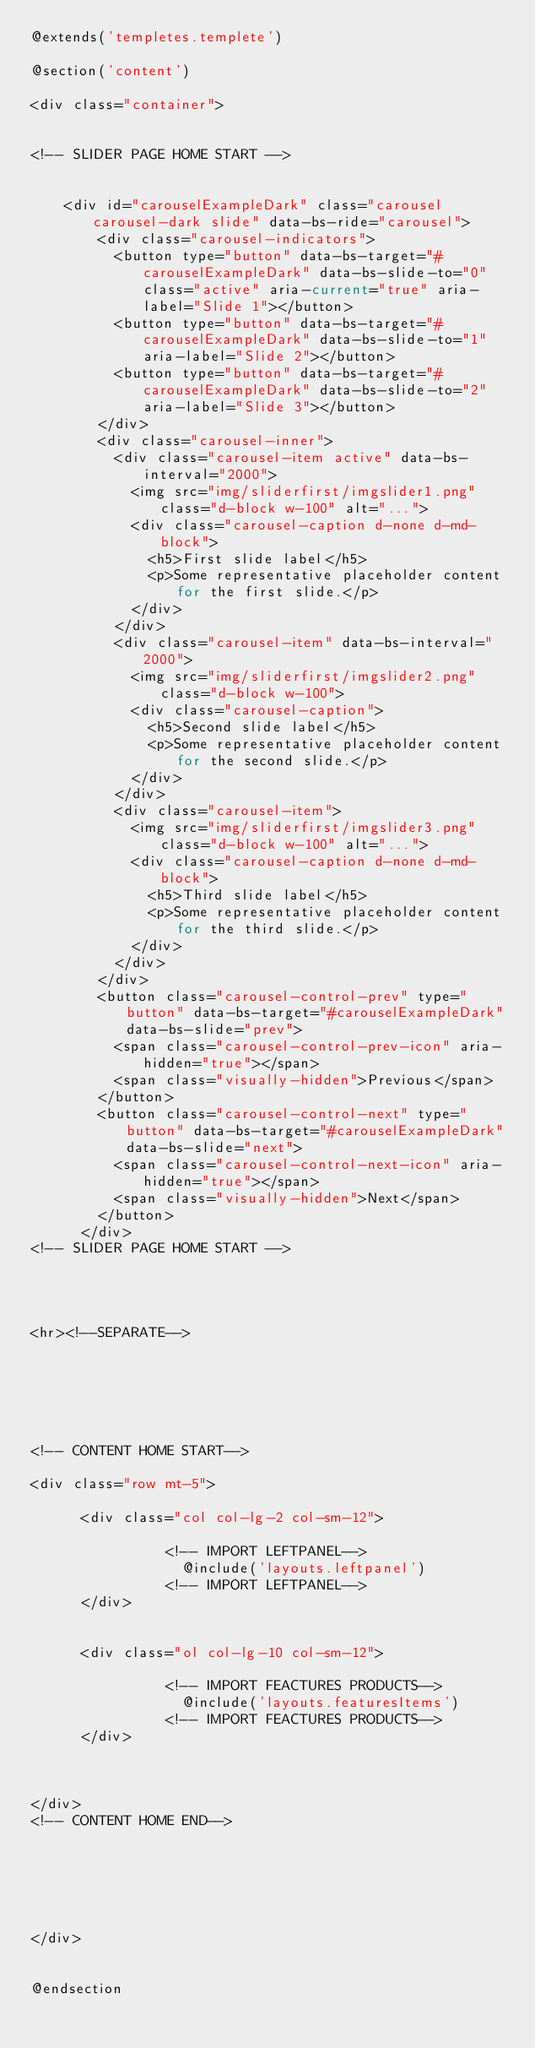<code> <loc_0><loc_0><loc_500><loc_500><_PHP_>@extends('templetes.templete')

@section('content')

<div class="container">


<!-- SLIDER PAGE HOME START -->


    <div id="carouselExampleDark" class="carousel carousel-dark slide" data-bs-ride="carousel">
        <div class="carousel-indicators">
          <button type="button" data-bs-target="#carouselExampleDark" data-bs-slide-to="0" class="active" aria-current="true" aria-label="Slide 1"></button>
          <button type="button" data-bs-target="#carouselExampleDark" data-bs-slide-to="1" aria-label="Slide 2"></button>
          <button type="button" data-bs-target="#carouselExampleDark" data-bs-slide-to="2" aria-label="Slide 3"></button>
        </div>
        <div class="carousel-inner">
          <div class="carousel-item active" data-bs-interval="2000">
            <img src="img/sliderfirst/imgslider1.png" class="d-block w-100" alt="...">
            <div class="carousel-caption d-none d-md-block">
              <h5>First slide label</h5>
              <p>Some representative placeholder content for the first slide.</p>
            </div>
          </div>
          <div class="carousel-item" data-bs-interval="2000">
            <img src="img/sliderfirst/imgslider2.png" class="d-block w-100">
            <div class="carousel-caption">
              <h5>Second slide label</h5>
              <p>Some representative placeholder content for the second slide.</p>
            </div>
          </div>
          <div class="carousel-item">
            <img src="img/sliderfirst/imgslider3.png" class="d-block w-100" alt="...">
            <div class="carousel-caption d-none d-md-block">
              <h5>Third slide label</h5>
              <p>Some representative placeholder content for the third slide.</p>
            </div>
          </div>
        </div>
        <button class="carousel-control-prev" type="button" data-bs-target="#carouselExampleDark" data-bs-slide="prev">
          <span class="carousel-control-prev-icon" aria-hidden="true"></span>
          <span class="visually-hidden">Previous</span>
        </button>
        <button class="carousel-control-next" type="button" data-bs-target="#carouselExampleDark" data-bs-slide="next">
          <span class="carousel-control-next-icon" aria-hidden="true"></span>
          <span class="visually-hidden">Next</span>
        </button>
      </div>
<!-- SLIDER PAGE HOME START -->




<hr><!--SEPARATE-->






<!-- CONTENT HOME START-->

<div class="row mt-5">

      <div class="col col-lg-2 col-sm-12">

                <!-- IMPORT LEFTPANEL-->
                  @include('layouts.leftpanel')
                <!-- IMPORT LEFTPANEL-->
      </div>


      <div class="ol col-lg-10 col-sm-12">
        
                <!-- IMPORT FEACTURES PRODUCTS-->
                  @include('layouts.featuresItems')
                <!-- IMPORT FEACTURES PRODUCTS-->
      </div>


  
</div>
<!-- CONTENT HOME END-->






</div>

    
@endsection</code> 